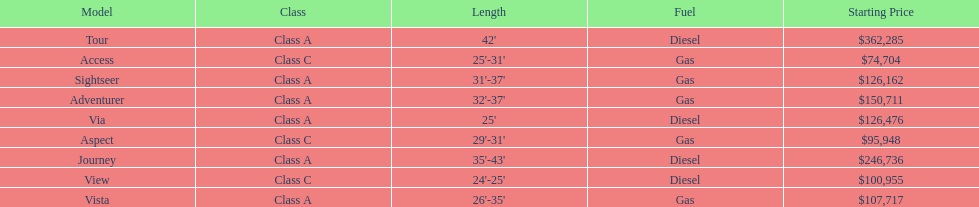Would you be able to parse every entry in this table? {'header': ['Model', 'Class', 'Length', 'Fuel', 'Starting Price'], 'rows': [['Tour', 'Class A', "42'", 'Diesel', '$362,285'], ['Access', 'Class C', "25'-31'", 'Gas', '$74,704'], ['Sightseer', 'Class A', "31'-37'", 'Gas', '$126,162'], ['Adventurer', 'Class A', "32'-37'", 'Gas', '$150,711'], ['Via', 'Class A', "25'", 'Diesel', '$126,476'], ['Aspect', 'Class C', "29'-31'", 'Gas', '$95,948'], ['Journey', 'Class A', "35'-43'", 'Diesel', '$246,736'], ['View', 'Class C', "24'-25'", 'Diesel', '$100,955'], ['Vista', 'Class A', "26'-35'", 'Gas', '$107,717']]} Which model has the lowest started price? Access. 